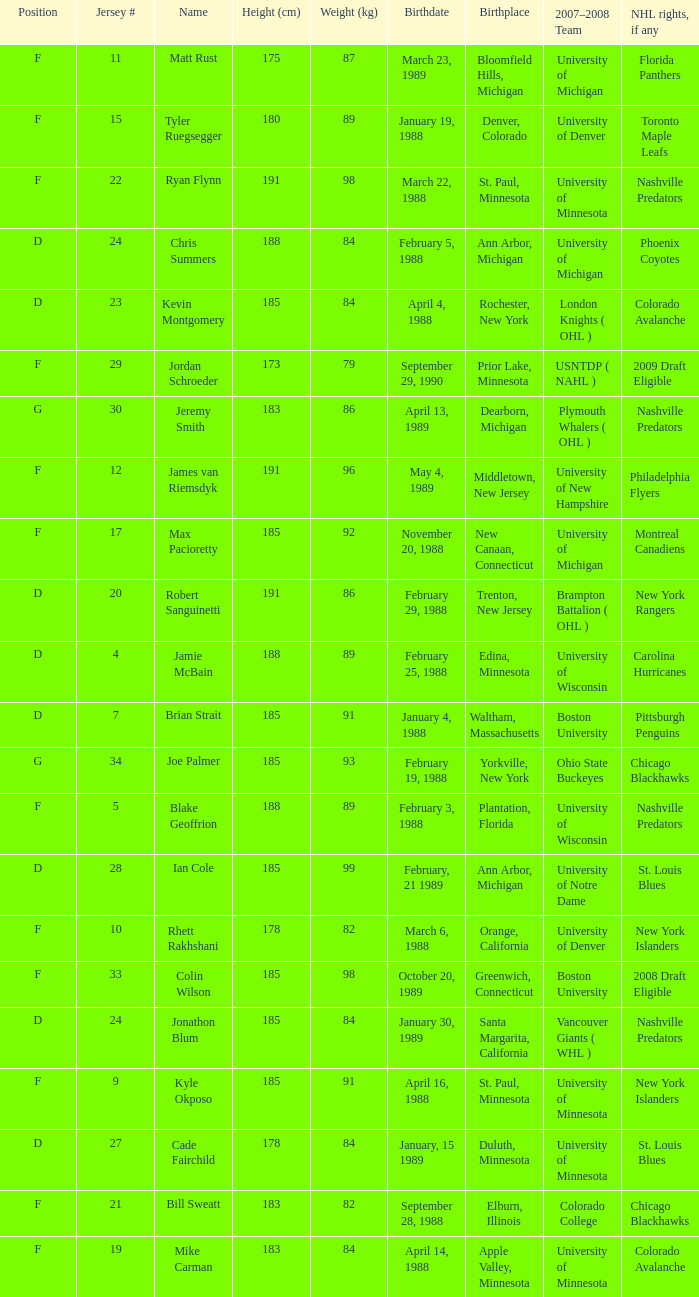Which Weight (kg) has a NHL rights, if any of phoenix coyotes? 1.0. 